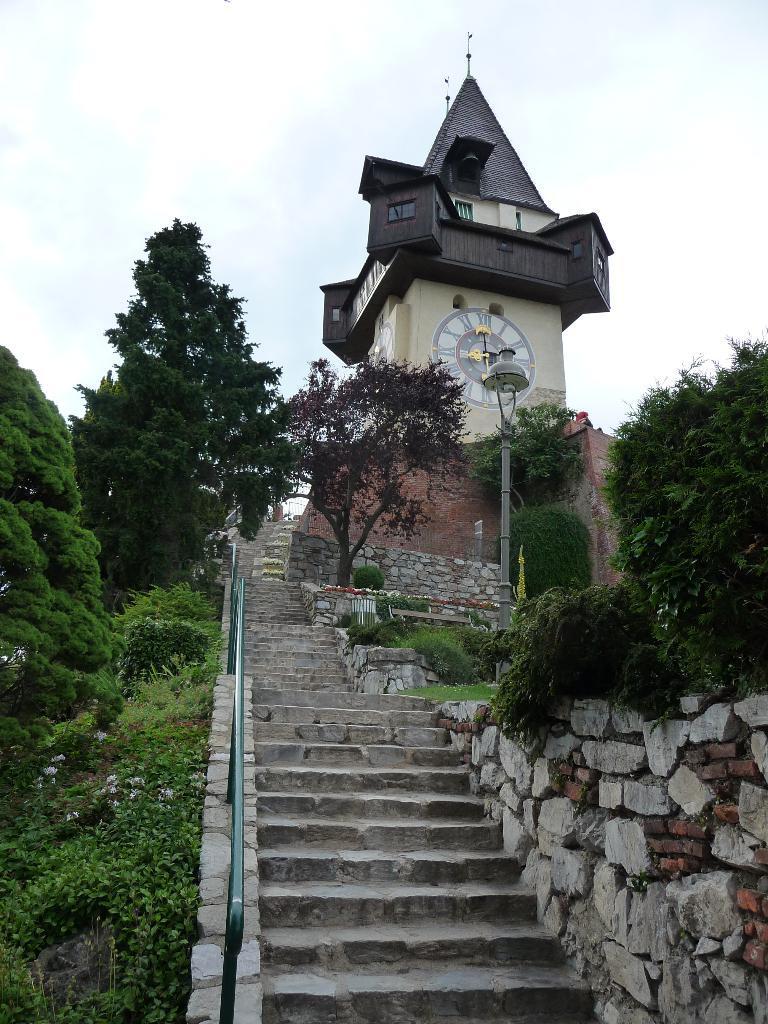How would you summarize this image in a sentence or two? In this image, we can see some trees and plants. There are steps at the bottom of the image. There is a clock tower in the middle of the image. There is a sky at the top of the image. There is a wall in the bottom right of the image. 